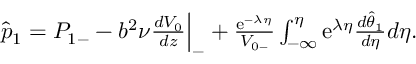<formula> <loc_0><loc_0><loc_500><loc_500>\begin{array} { r } { \hat { p } _ { 1 } = P _ { 1 - } - b ^ { 2 } \nu \frac { d V _ { 0 } } { d z } \Big | _ { - } + \frac { e ^ { - \lambda \eta } } { V _ { 0 - } } \int _ { - \infty } ^ { \eta } e ^ { \lambda \eta } \frac { d \hat { \theta } _ { 1 } } { d \eta } d \eta . } \end{array}</formula> 